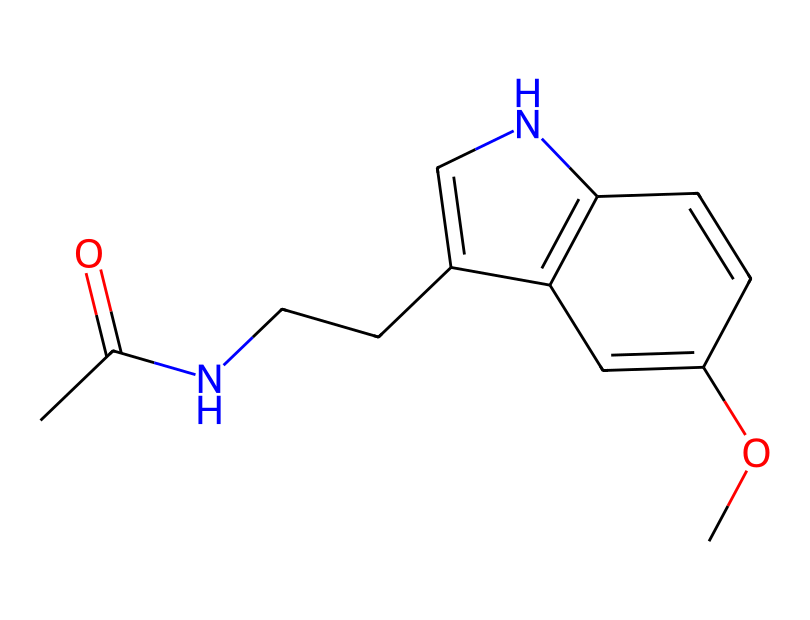What is the molecular formula of this chemical? To determine the molecular formula, we can count the atoms present in the structure from the SMILES notation. The SMILES represents carbon (C), hydrogen (H), nitrogen (N), and oxygen (O) atoms. The count shows there are 13 carbons, 16 hydrogens, 2 nitrogens, and 1 oxygen. Therefore, the molecular formula is C13H16N2O.
Answer: C13H16N2O How many nitrogen atoms are present in this chemical? In the provided SMILES, we can identify the nitrogen atoms (N). By examining the structure or the SMILES itself, we find 2 nitrogen atoms present in the chemical.
Answer: 2 What is the functional group represented in this compound? The functional groups in this compound can include an amide (from the acetyl group, CC(=O)N) and an ether (from the –O– in the OCH3 part). This highlights the compound's role as a hormone.
Answer: amide and ether What property of this chemical is affected by city lights? City lights interfere with the natural light-dark cycle, which affects melatonin production, a critical hormone for sleep regulation. It is synthesized in response to darkness and inhibited by light exposure, specifically blue light.
Answer: sleep regulation Describe how this chemical's structure relates to its function as a hormone. The molecular structure of melatonin is crucial for its interaction with melatonin receptors in the brain, regulating circadian rhythms. The presence of the indole ring, alongside the amide group, enables binding to these receptors, thus influencing sleep patterns.
Answer: interaction with receptors How might the presence of city lights influence melatonin production? City lights, especially blue light, can inhibit the production of melatonin by affecting the pineal gland's signaling process. This results from reduced darkness, which is necessary for melatonin secretion, leading to disrupted sleep-wake cycles.
Answer: inhibited production How does the structure of melatonin allow it to traverse cellular membranes? The lipophilic nature of melatonin, due to its hydrophobic carbon chain and relatively small size, allows it to easily pass through lipid bilayers of cell membranes, facilitating its quick action in the body.
Answer: lipophilic nature 